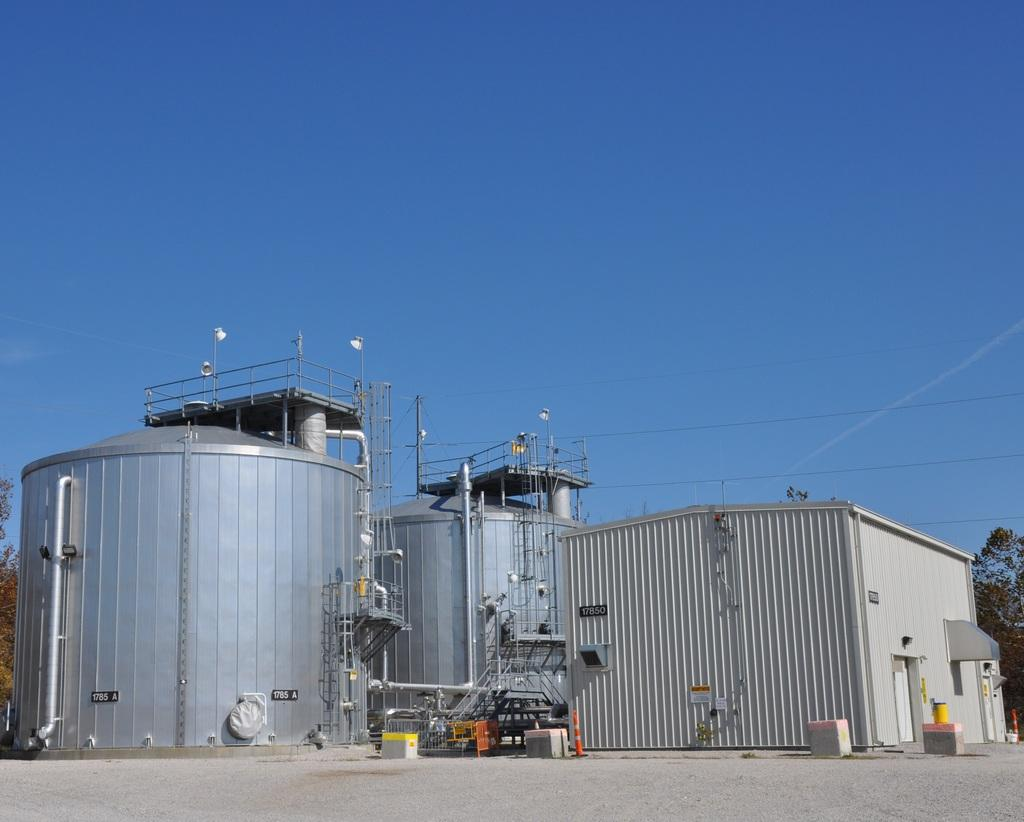What type of objects can be seen in the image? There are containers, a shed, railing, trees, and other objects in the image. Can you describe the background of the image? The background of the image includes the blue sky. What type of structure is present in the image? There is a shed in the image. Are there any natural elements visible in the image? Yes, there are trees in the image. What type of learning can be observed in the image? There is no learning activity depicted in the image. What type of amusement is present in the image? There is no amusement activity depicted in the image. 